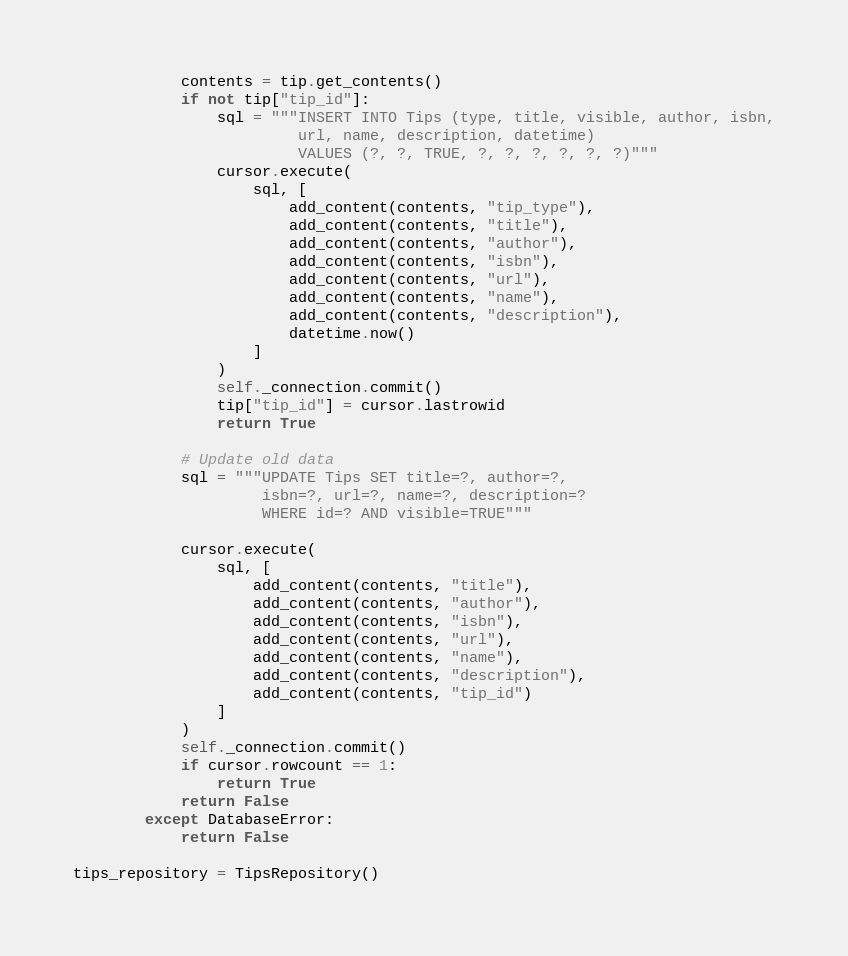<code> <loc_0><loc_0><loc_500><loc_500><_Python_>            contents = tip.get_contents()
            if not tip["tip_id"]:
                sql = """INSERT INTO Tips (type, title, visible, author, isbn,
                         url, name, description, datetime)
                         VALUES (?, ?, TRUE, ?, ?, ?, ?, ?, ?)"""
                cursor.execute(
                    sql, [
                        add_content(contents, "tip_type"),
                        add_content(contents, "title"),
                        add_content(contents, "author"),
                        add_content(contents, "isbn"),
                        add_content(contents, "url"),
                        add_content(contents, "name"),
                        add_content(contents, "description"),
                        datetime.now()
                    ]
                )
                self._connection.commit()
                tip["tip_id"] = cursor.lastrowid
                return True

            # Update old data
            sql = """UPDATE Tips SET title=?, author=?,
                     isbn=?, url=?, name=?, description=?
                     WHERE id=? AND visible=TRUE"""

            cursor.execute(
                sql, [
                    add_content(contents, "title"),
                    add_content(contents, "author"),
                    add_content(contents, "isbn"),
                    add_content(contents, "url"),
                    add_content(contents, "name"),
                    add_content(contents, "description"),
                    add_content(contents, "tip_id")
                ]
            )
            self._connection.commit()
            if cursor.rowcount == 1:
                return True
            return False
        except DatabaseError:
            return False

tips_repository = TipsRepository()
</code> 